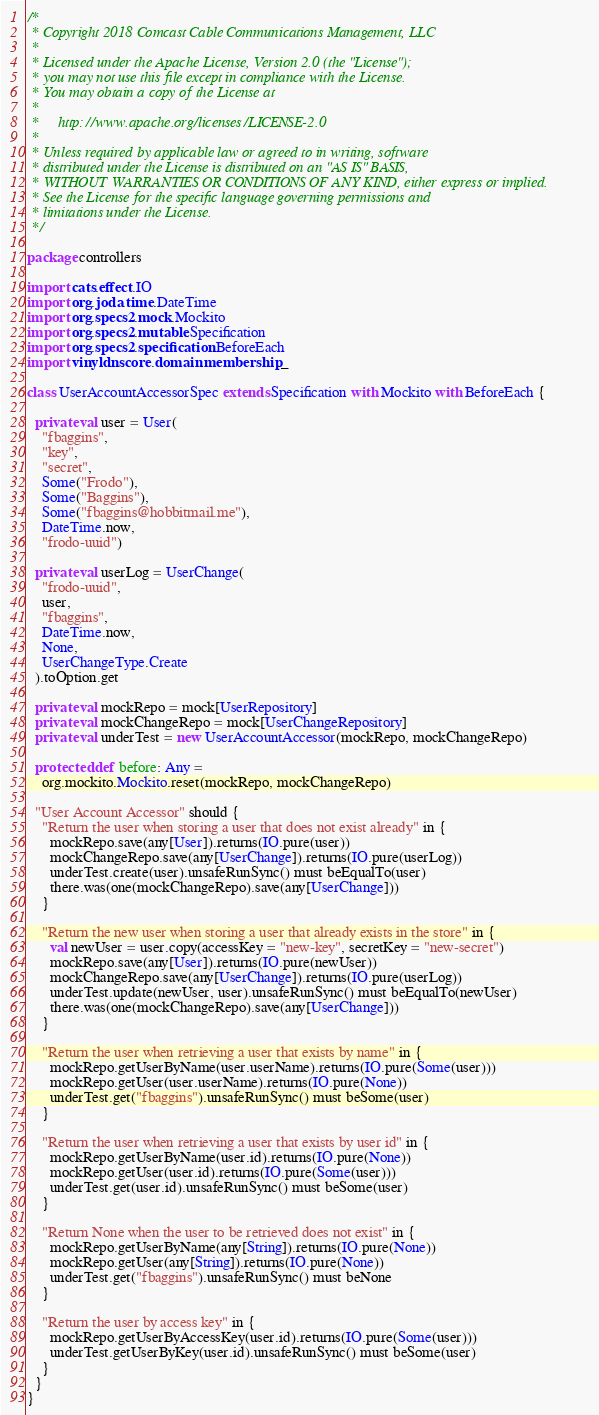<code> <loc_0><loc_0><loc_500><loc_500><_Scala_>/*
 * Copyright 2018 Comcast Cable Communications Management, LLC
 *
 * Licensed under the Apache License, Version 2.0 (the "License");
 * you may not use this file except in compliance with the License.
 * You may obtain a copy of the License at
 *
 *     http://www.apache.org/licenses/LICENSE-2.0
 *
 * Unless required by applicable law or agreed to in writing, software
 * distributed under the License is distributed on an "AS IS" BASIS,
 * WITHOUT WARRANTIES OR CONDITIONS OF ANY KIND, either express or implied.
 * See the License for the specific language governing permissions and
 * limitations under the License.
 */

package controllers

import cats.effect.IO
import org.joda.time.DateTime
import org.specs2.mock.Mockito
import org.specs2.mutable.Specification
import org.specs2.specification.BeforeEach
import vinyldns.core.domain.membership._

class UserAccountAccessorSpec extends Specification with Mockito with BeforeEach {

  private val user = User(
    "fbaggins",
    "key",
    "secret",
    Some("Frodo"),
    Some("Baggins"),
    Some("fbaggins@hobbitmail.me"),
    DateTime.now,
    "frodo-uuid")

  private val userLog = UserChange(
    "frodo-uuid",
    user,
    "fbaggins",
    DateTime.now,
    None,
    UserChangeType.Create
  ).toOption.get

  private val mockRepo = mock[UserRepository]
  private val mockChangeRepo = mock[UserChangeRepository]
  private val underTest = new UserAccountAccessor(mockRepo, mockChangeRepo)

  protected def before: Any =
    org.mockito.Mockito.reset(mockRepo, mockChangeRepo)

  "User Account Accessor" should {
    "Return the user when storing a user that does not exist already" in {
      mockRepo.save(any[User]).returns(IO.pure(user))
      mockChangeRepo.save(any[UserChange]).returns(IO.pure(userLog))
      underTest.create(user).unsafeRunSync() must beEqualTo(user)
      there.was(one(mockChangeRepo).save(any[UserChange]))
    }

    "Return the new user when storing a user that already exists in the store" in {
      val newUser = user.copy(accessKey = "new-key", secretKey = "new-secret")
      mockRepo.save(any[User]).returns(IO.pure(newUser))
      mockChangeRepo.save(any[UserChange]).returns(IO.pure(userLog))
      underTest.update(newUser, user).unsafeRunSync() must beEqualTo(newUser)
      there.was(one(mockChangeRepo).save(any[UserChange]))
    }

    "Return the user when retrieving a user that exists by name" in {
      mockRepo.getUserByName(user.userName).returns(IO.pure(Some(user)))
      mockRepo.getUser(user.userName).returns(IO.pure(None))
      underTest.get("fbaggins").unsafeRunSync() must beSome(user)
    }

    "Return the user when retrieving a user that exists by user id" in {
      mockRepo.getUserByName(user.id).returns(IO.pure(None))
      mockRepo.getUser(user.id).returns(IO.pure(Some(user)))
      underTest.get(user.id).unsafeRunSync() must beSome(user)
    }

    "Return None when the user to be retrieved does not exist" in {
      mockRepo.getUserByName(any[String]).returns(IO.pure(None))
      mockRepo.getUser(any[String]).returns(IO.pure(None))
      underTest.get("fbaggins").unsafeRunSync() must beNone
    }

    "Return the user by access key" in {
      mockRepo.getUserByAccessKey(user.id).returns(IO.pure(Some(user)))
      underTest.getUserByKey(user.id).unsafeRunSync() must beSome(user)
    }
  }
}
</code> 